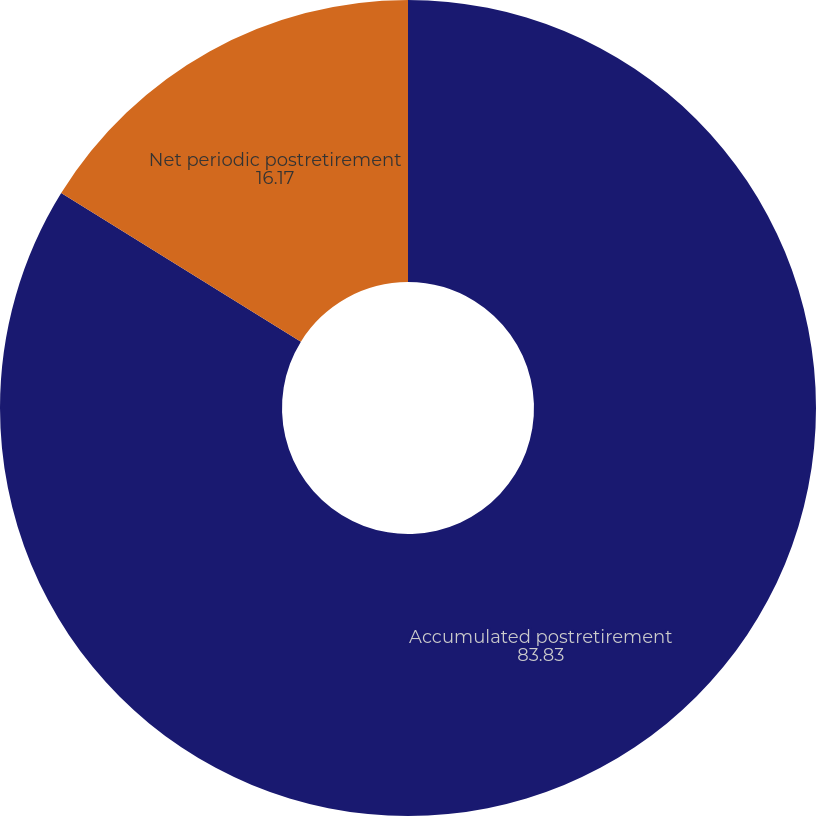Convert chart to OTSL. <chart><loc_0><loc_0><loc_500><loc_500><pie_chart><fcel>Accumulated postretirement<fcel>Net periodic postretirement<nl><fcel>83.83%<fcel>16.17%<nl></chart> 